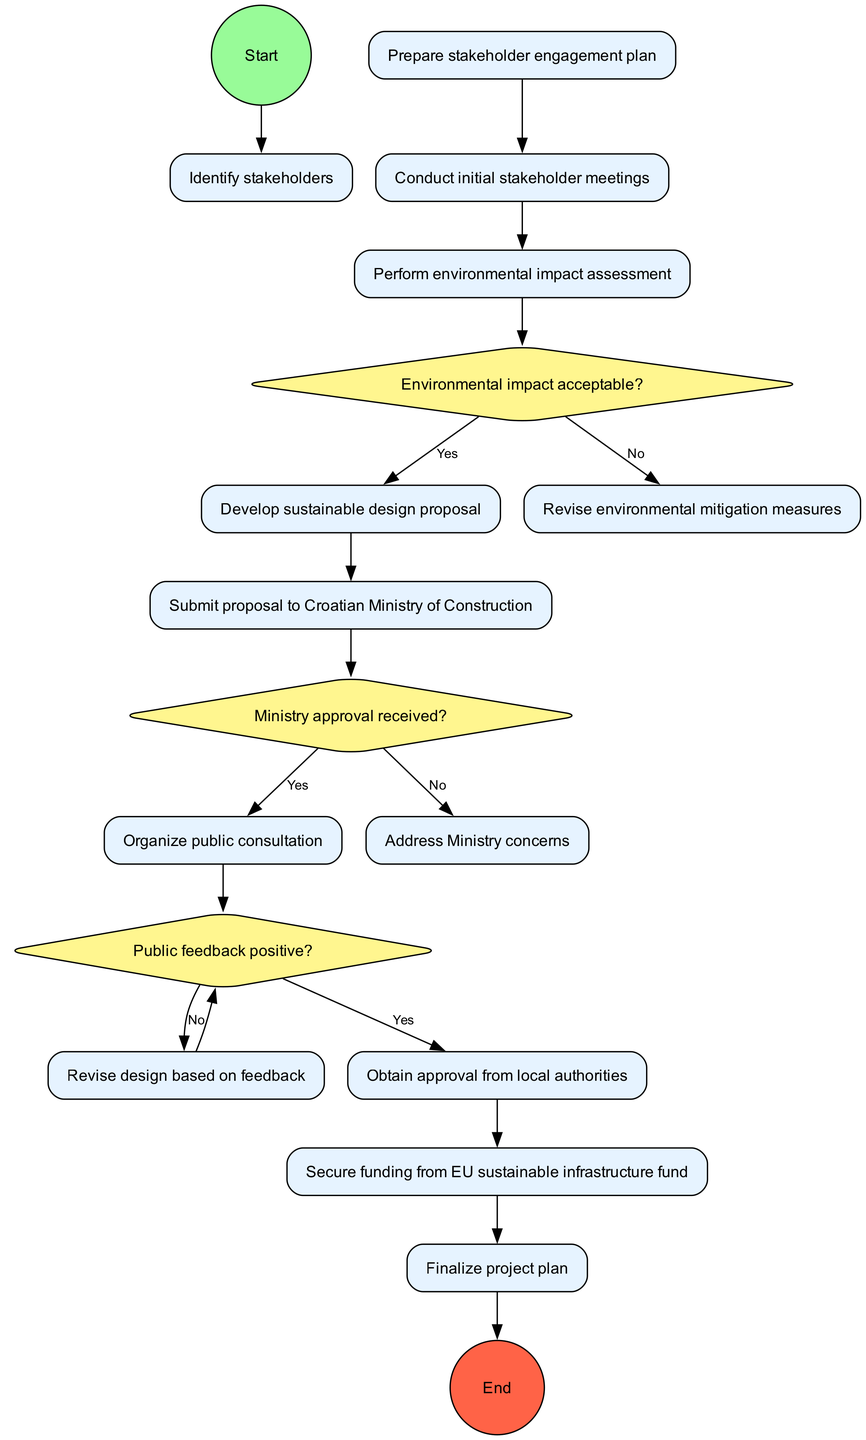What is the first activity in the diagram? The initial node specified in the data is "Identify stakeholders," which signifies the first activity to be undertaken. It serves as the starting point for all subsequent activities.
Answer: Identify stakeholders How many activities are included in the diagram? By counting the listed activities in the data, there are a total of 10 distinct activities outlined in the diagram. This includes all processes from stakeholder engagement to project plan finalization.
Answer: 10 What decision follows the "Perform environmental impact assessment" activity? After this activity, the next step is a decision node that asks, "Environmental impact acceptable?" Based on the response to this question, the diagram routes flow accordingly.
Answer: Environmental impact acceptable? Which activity is connected to the "Submit proposal to Croatian Ministry of Construction"? The activity that comes after this submission is the decision node labeled "Ministry approval received?" This indicates that the diagram evaluates the proposal's acceptance before any further actions are taken.
Answer: Ministry approval received? If the answer to "Public feedback positive?" is no, which activity occurs next? In this scenario, if public feedback is negative, the flow leads back to "Revise design based on feedback." This reflects the need to adjust the project based on public input before seeking further approvals.
Answer: Revise design based on feedback What is the result of obtaining approval from local authorities? Once local authorities grant approval, the process moves on to the final activity labeled "Finalize project plan," indicating readiness to conclude planning and commence construction.
Answer: Finalize project plan How does the "Conduct initial stakeholder meetings" activity relate to the "Prepare stakeholder engagement plan"? "Conduct initial stakeholder meetings" directly follows "Prepare stakeholder engagement plan," indicating a sequential relationship where planning meetings are a vital next step after creating the engagement strategy.
Answer: Sequential relationship What could happen if the Ministry approval is not received? If Ministry approval is not granted, the flow directs to the activity labeled "Address Ministry concerns." This suggests resolving any issues raised by the Ministry before retaking steps towards approval.
Answer: Address Ministry concerns What is the final node in the diagram? The last node in the diagram is labeled "Begin construction phase," signifying the conclusion of the planning and approval processes and the start of actual construction.
Answer: Begin construction phase 